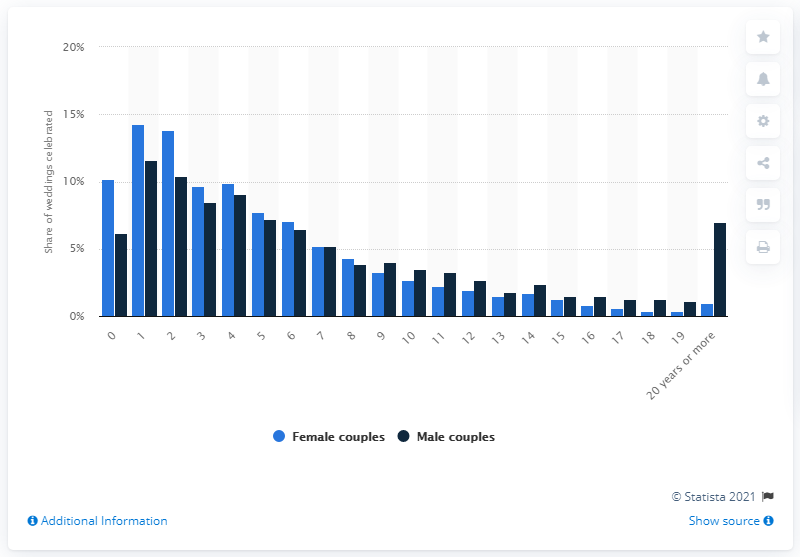Identify some key points in this picture. In 2017, one percent of marriages between two women involved spouses with a difference in age of 20 years or more. 